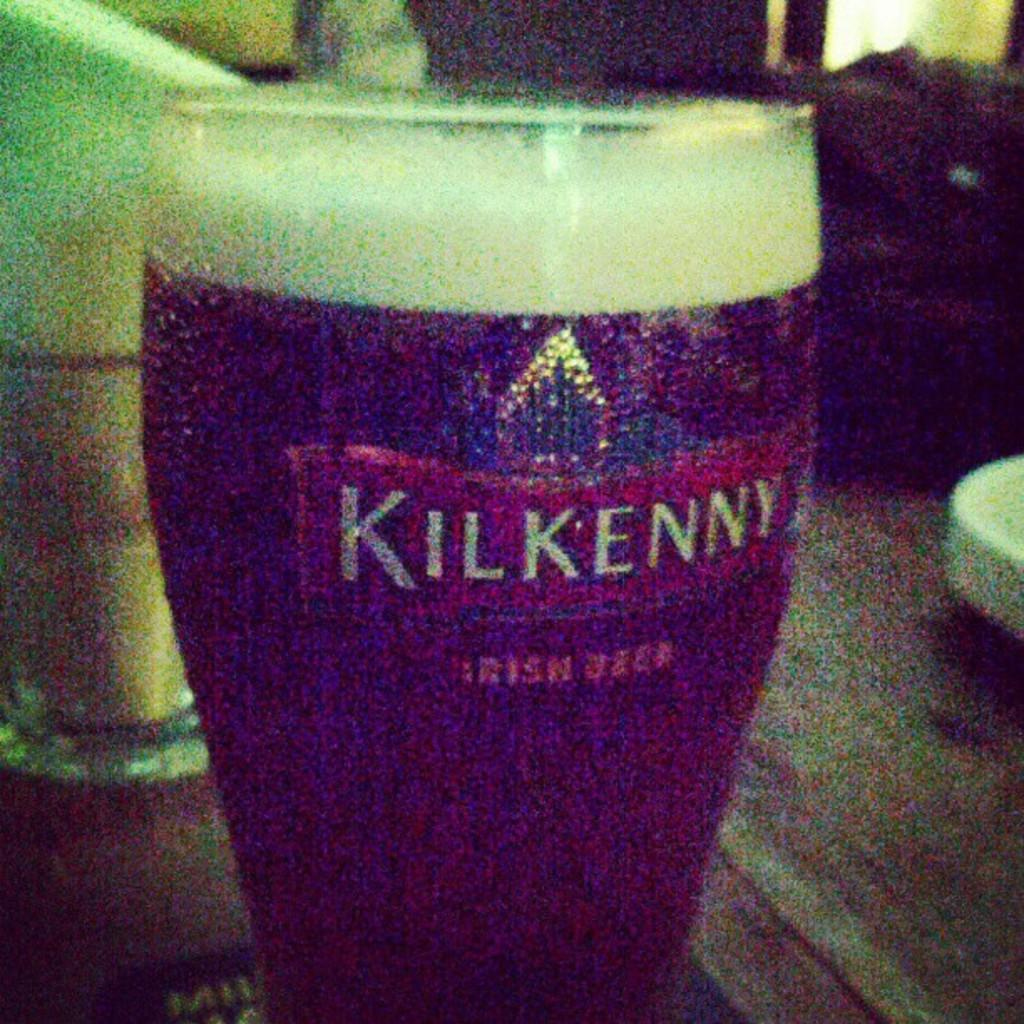Provide a one-sentence caption for the provided image. The drink in the glass is called Irish Beer. 